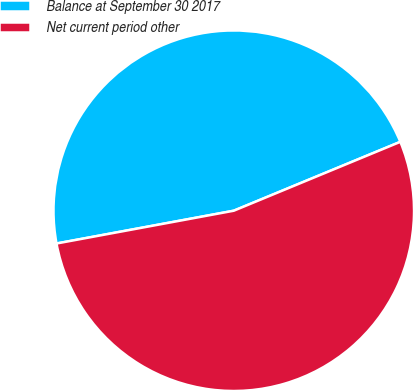Convert chart to OTSL. <chart><loc_0><loc_0><loc_500><loc_500><pie_chart><fcel>Balance at September 30 2017<fcel>Net current period other<nl><fcel>46.67%<fcel>53.33%<nl></chart> 